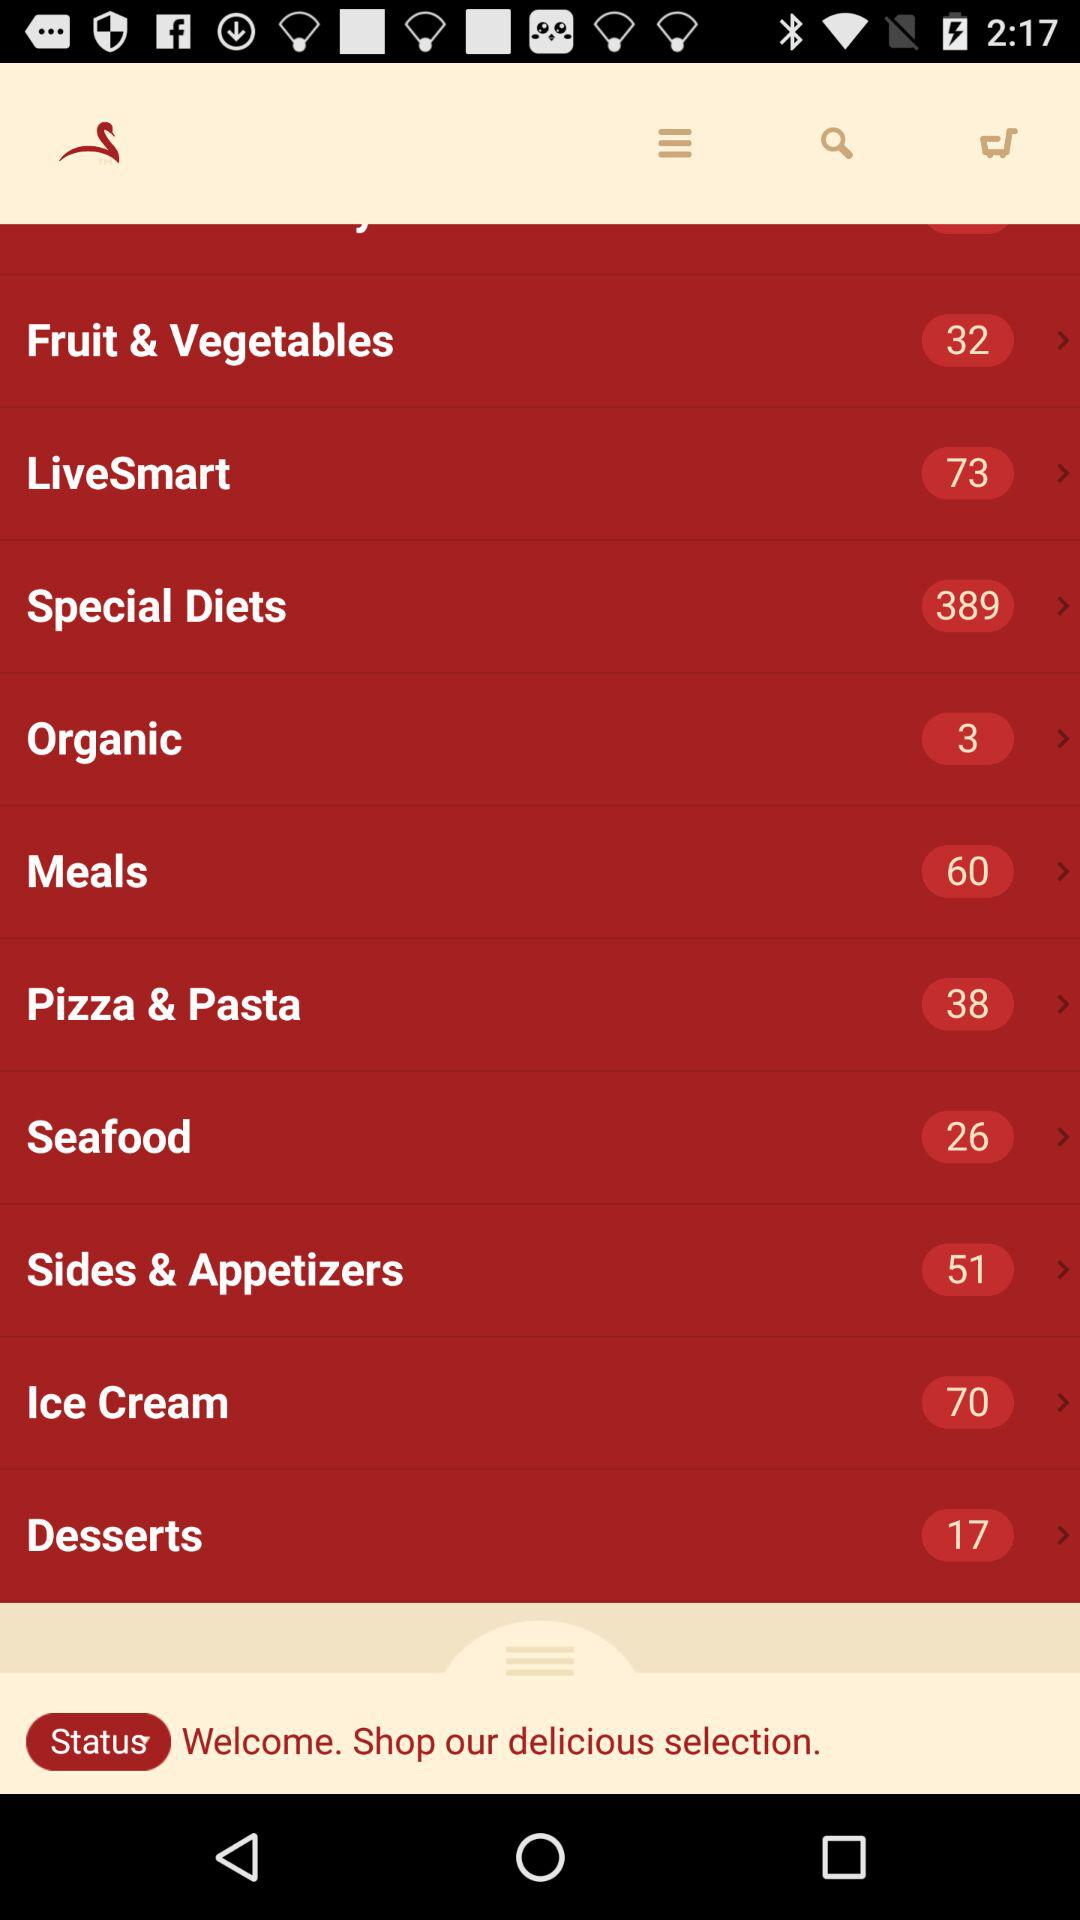What is the total number of meals available? The total number of meals is 60. 